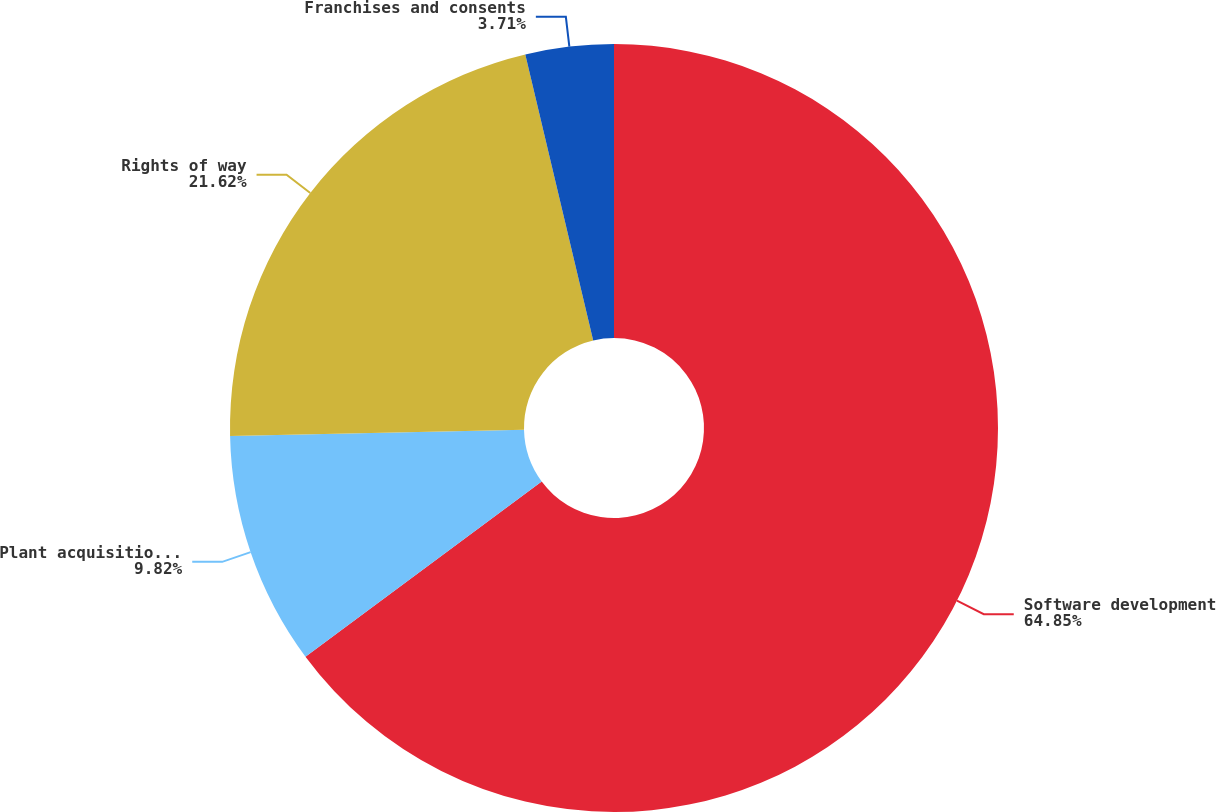<chart> <loc_0><loc_0><loc_500><loc_500><pie_chart><fcel>Software development<fcel>Plant acquisition adjustments<fcel>Rights of way<fcel>Franchises and consents<nl><fcel>64.85%<fcel>9.82%<fcel>21.62%<fcel>3.71%<nl></chart> 